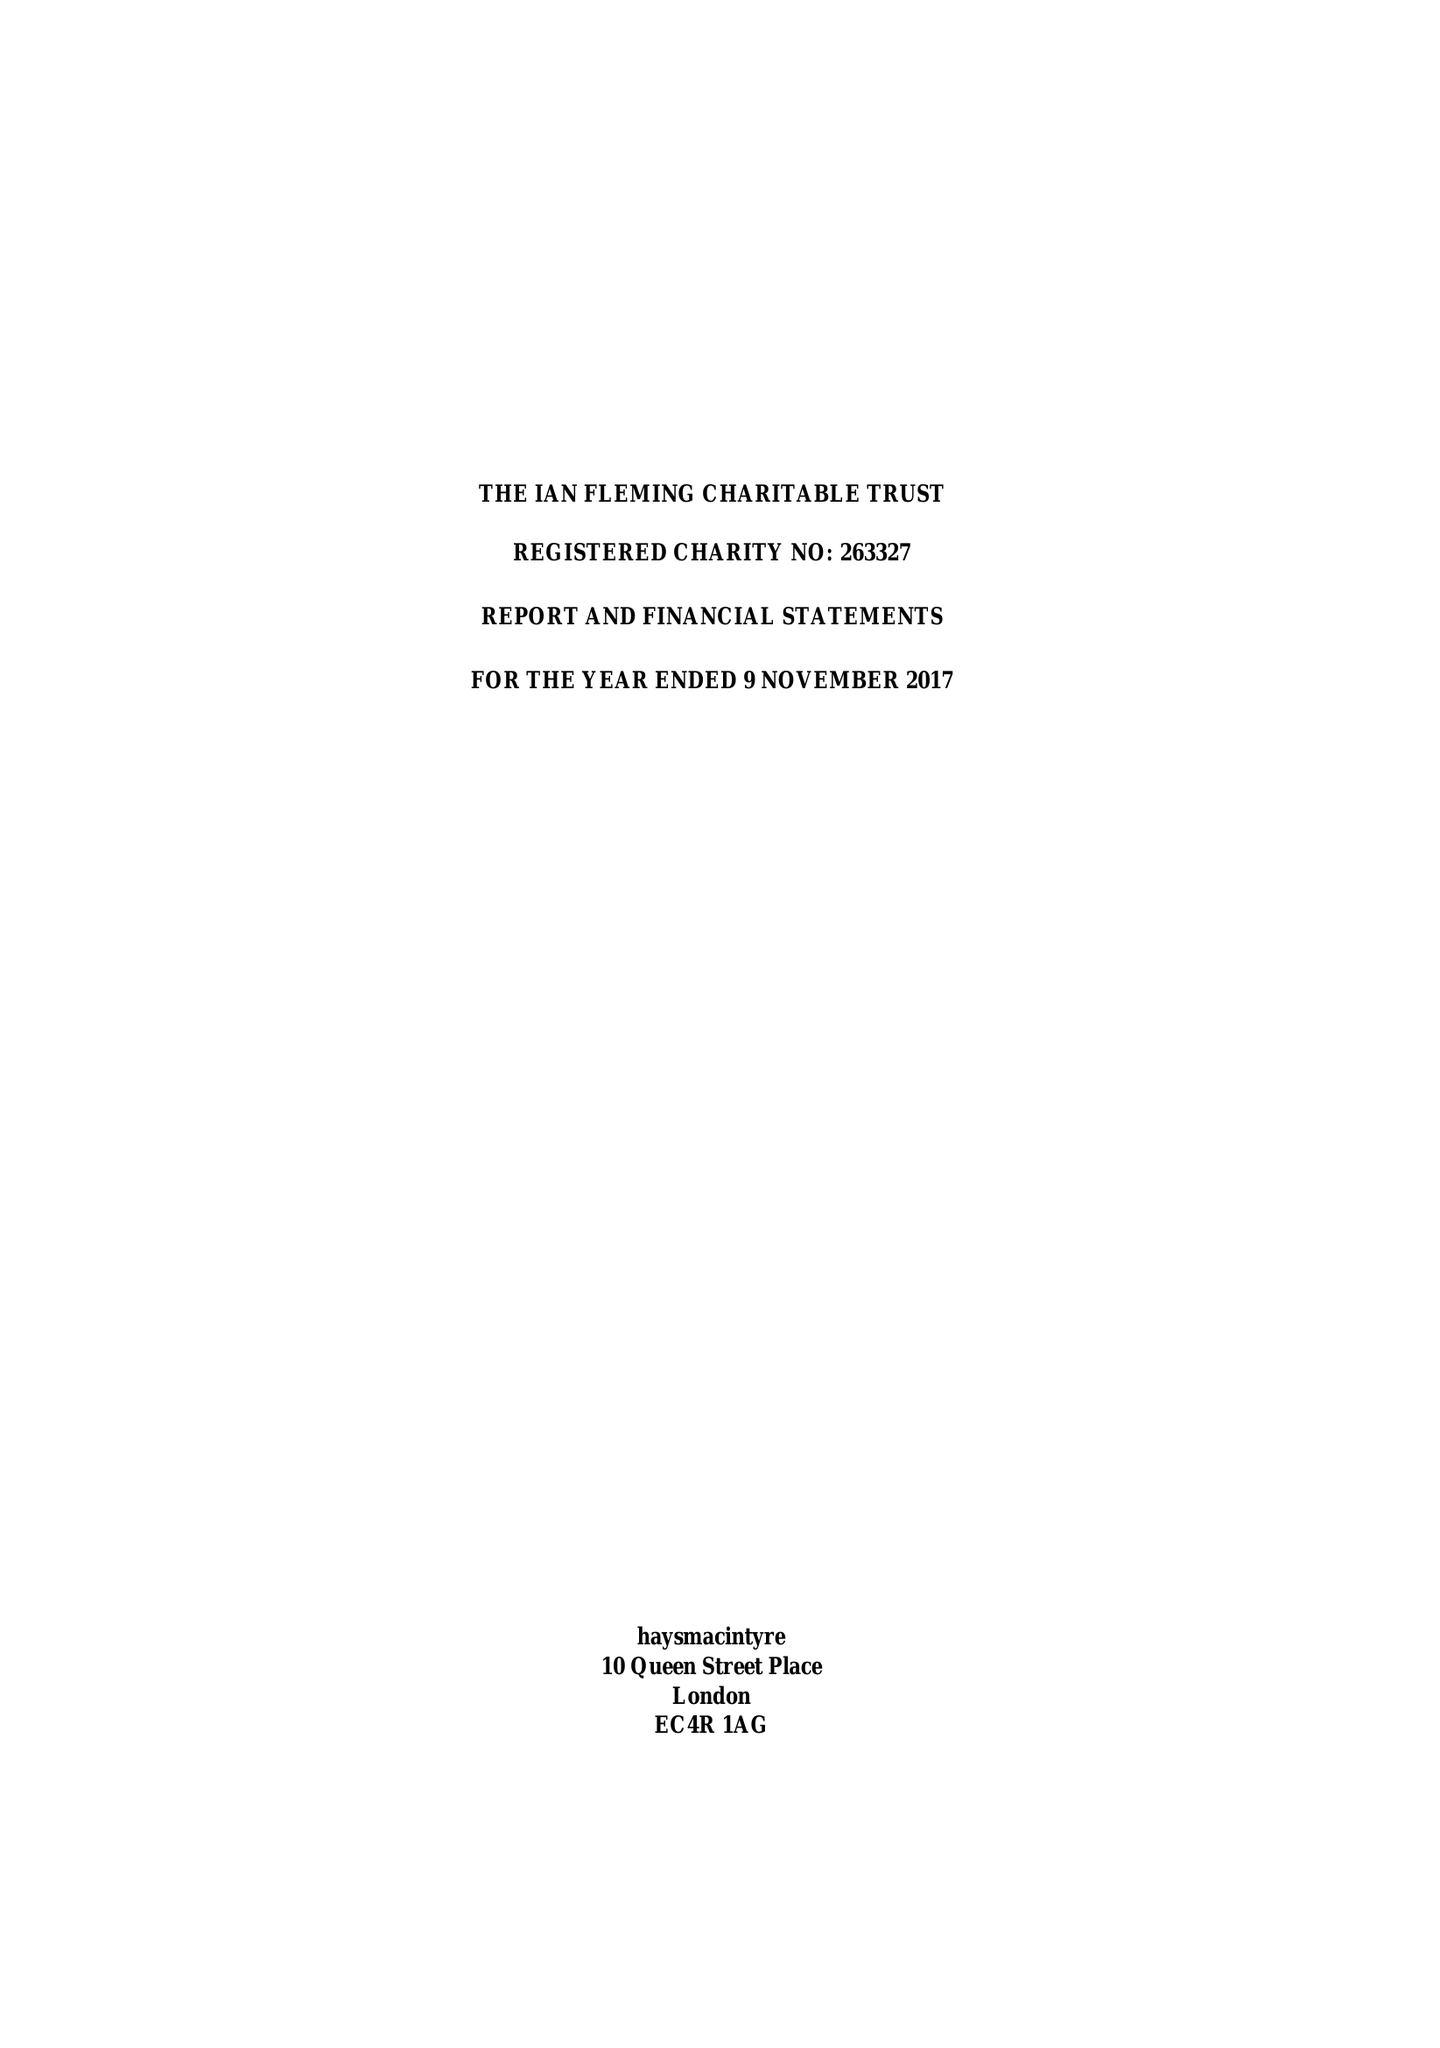What is the value for the charity_number?
Answer the question using a single word or phrase. 263327 